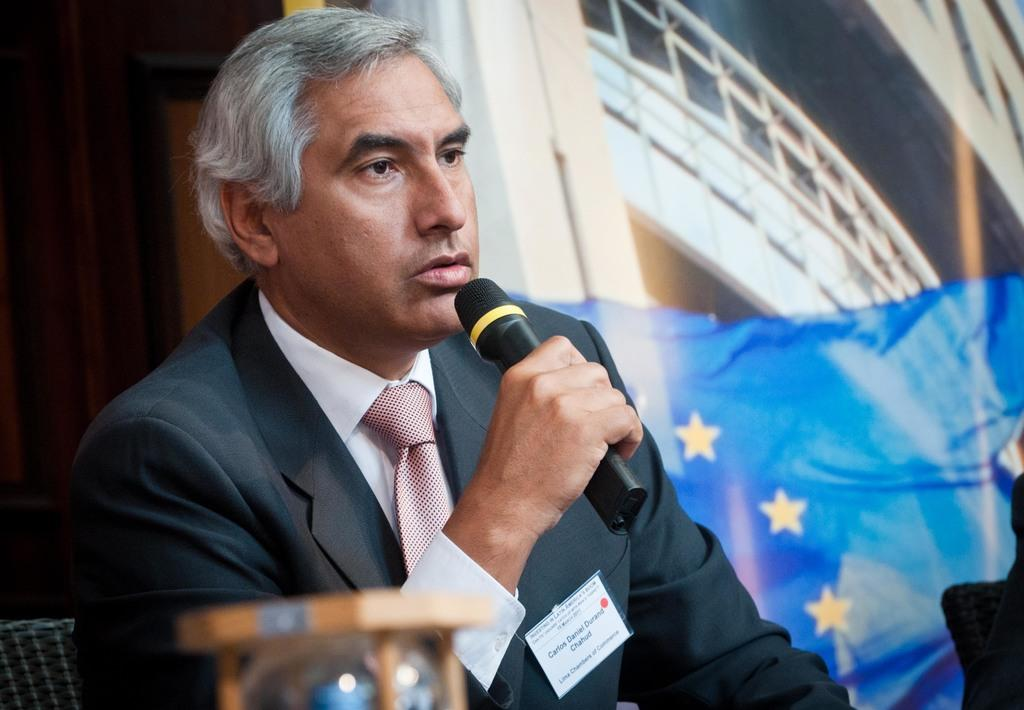What is the main subject of the image? The main subject of the image is a man. What is the man wearing? The man is wearing a blazer and a tie. What is the man holding in his hand? The man is holding a microphone in his hand. What other objects or structures can be seen in the image? There is a pillar with a pipe and a fence in the image. What type of pot is visible in the image? There is no pot present in the image. What type of building can be seen in the background of the image? The image does not show a building in the background; it only features a man, a pillar with a pipe, and a fence. 